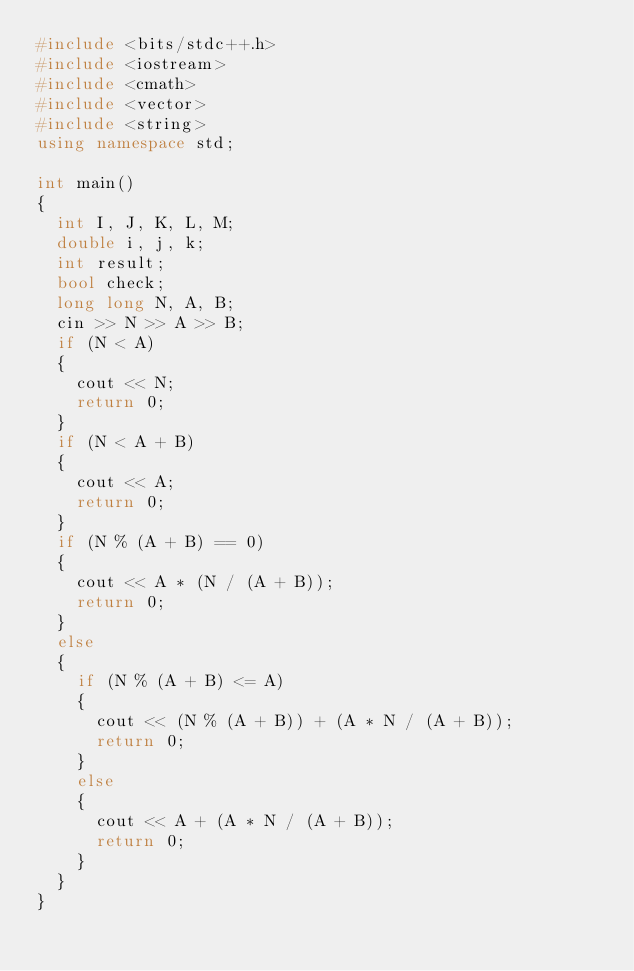<code> <loc_0><loc_0><loc_500><loc_500><_C++_>#include <bits/stdc++.h>
#include <iostream>
#include <cmath>
#include <vector>
#include <string>
using namespace std;

int main()
{
  int I, J, K, L, M;
  double i, j, k;
  int result;
  bool check;
  long long N, A, B;
  cin >> N >> A >> B;
  if (N < A)
  {
    cout << N;
    return 0;
  }
  if (N < A + B)
  {
    cout << A;
    return 0;
  }
  if (N % (A + B) == 0)
  {
    cout << A * (N / (A + B));
    return 0;
  }
  else
  {
    if (N % (A + B) <= A)
    {
      cout << (N % (A + B)) + (A * N / (A + B));
      return 0;
    }
    else
    {
      cout << A + (A * N / (A + B));
      return 0;
    }
  }
}</code> 